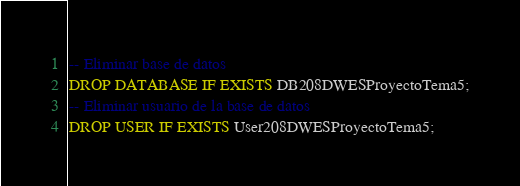<code> <loc_0><loc_0><loc_500><loc_500><_SQL_>-- Eliminar base de datos
DROP DATABASE IF EXISTS DB208DWESProyectoTema5;
-- Eliminar usuario de la base de datos
DROP USER IF EXISTS User208DWESProyectoTema5;
</code> 